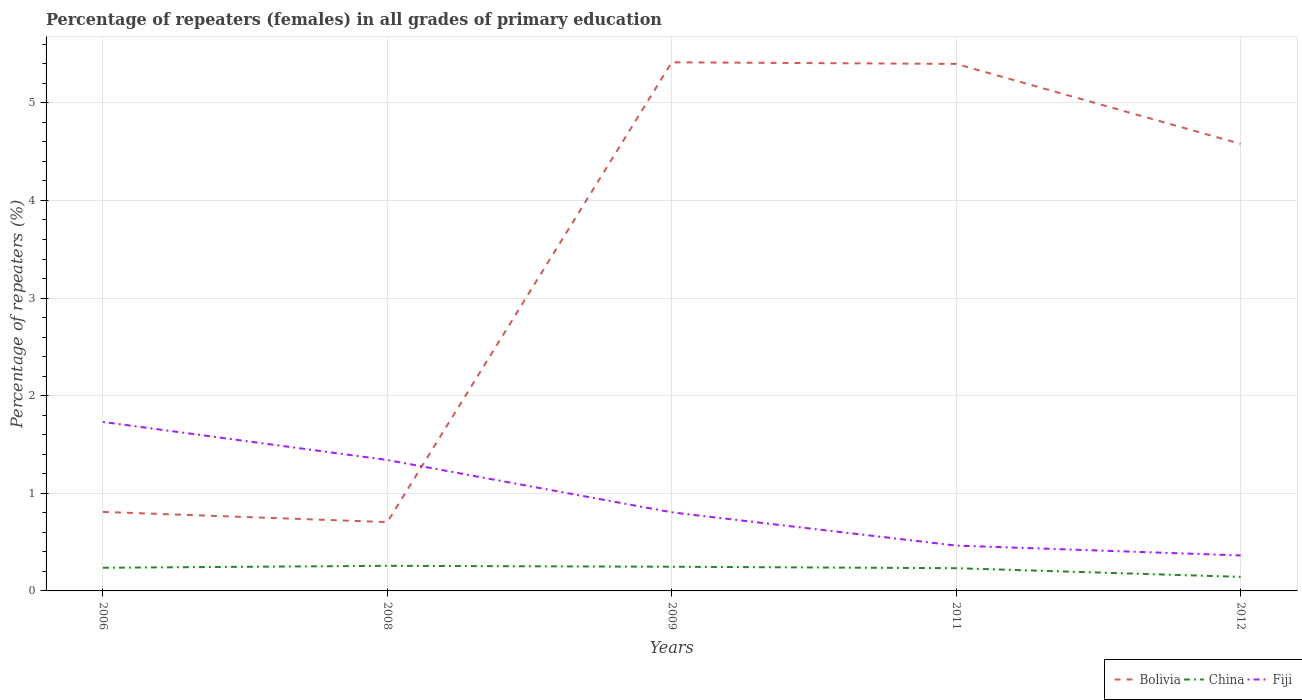Across all years, what is the maximum percentage of repeaters (females) in China?
Your response must be concise. 0.14. In which year was the percentage of repeaters (females) in Bolivia maximum?
Your answer should be very brief. 2008. What is the total percentage of repeaters (females) in Bolivia in the graph?
Offer a terse response. -3.87. What is the difference between the highest and the second highest percentage of repeaters (females) in Fiji?
Offer a terse response. 1.37. What is the difference between the highest and the lowest percentage of repeaters (females) in Bolivia?
Make the answer very short. 3. How many lines are there?
Ensure brevity in your answer.  3. How many years are there in the graph?
Keep it short and to the point. 5. What is the difference between two consecutive major ticks on the Y-axis?
Provide a succinct answer. 1. Are the values on the major ticks of Y-axis written in scientific E-notation?
Offer a very short reply. No. How many legend labels are there?
Your answer should be very brief. 3. What is the title of the graph?
Your answer should be compact. Percentage of repeaters (females) in all grades of primary education. What is the label or title of the X-axis?
Offer a very short reply. Years. What is the label or title of the Y-axis?
Ensure brevity in your answer.  Percentage of repeaters (%). What is the Percentage of repeaters (%) of Bolivia in 2006?
Your response must be concise. 0.81. What is the Percentage of repeaters (%) in China in 2006?
Provide a succinct answer. 0.24. What is the Percentage of repeaters (%) in Fiji in 2006?
Provide a short and direct response. 1.73. What is the Percentage of repeaters (%) in Bolivia in 2008?
Your answer should be very brief. 0.71. What is the Percentage of repeaters (%) in China in 2008?
Provide a succinct answer. 0.26. What is the Percentage of repeaters (%) in Fiji in 2008?
Your answer should be compact. 1.34. What is the Percentage of repeaters (%) of Bolivia in 2009?
Make the answer very short. 5.42. What is the Percentage of repeaters (%) in China in 2009?
Your answer should be very brief. 0.25. What is the Percentage of repeaters (%) of Fiji in 2009?
Provide a succinct answer. 0.8. What is the Percentage of repeaters (%) of Bolivia in 2011?
Keep it short and to the point. 5.4. What is the Percentage of repeaters (%) in China in 2011?
Offer a very short reply. 0.23. What is the Percentage of repeaters (%) in Fiji in 2011?
Your answer should be very brief. 0.46. What is the Percentage of repeaters (%) of Bolivia in 2012?
Keep it short and to the point. 4.58. What is the Percentage of repeaters (%) of China in 2012?
Your response must be concise. 0.14. What is the Percentage of repeaters (%) in Fiji in 2012?
Your response must be concise. 0.36. Across all years, what is the maximum Percentage of repeaters (%) in Bolivia?
Give a very brief answer. 5.42. Across all years, what is the maximum Percentage of repeaters (%) in China?
Provide a short and direct response. 0.26. Across all years, what is the maximum Percentage of repeaters (%) of Fiji?
Provide a succinct answer. 1.73. Across all years, what is the minimum Percentage of repeaters (%) in Bolivia?
Offer a very short reply. 0.71. Across all years, what is the minimum Percentage of repeaters (%) in China?
Provide a succinct answer. 0.14. Across all years, what is the minimum Percentage of repeaters (%) in Fiji?
Your answer should be very brief. 0.36. What is the total Percentage of repeaters (%) of Bolivia in the graph?
Your response must be concise. 16.91. What is the total Percentage of repeaters (%) in China in the graph?
Your answer should be very brief. 1.12. What is the total Percentage of repeaters (%) of Fiji in the graph?
Offer a terse response. 4.71. What is the difference between the Percentage of repeaters (%) of Bolivia in 2006 and that in 2008?
Provide a short and direct response. 0.1. What is the difference between the Percentage of repeaters (%) of China in 2006 and that in 2008?
Your answer should be very brief. -0.02. What is the difference between the Percentage of repeaters (%) in Fiji in 2006 and that in 2008?
Give a very brief answer. 0.39. What is the difference between the Percentage of repeaters (%) in Bolivia in 2006 and that in 2009?
Offer a very short reply. -4.61. What is the difference between the Percentage of repeaters (%) in China in 2006 and that in 2009?
Ensure brevity in your answer.  -0.01. What is the difference between the Percentage of repeaters (%) of Fiji in 2006 and that in 2009?
Make the answer very short. 0.93. What is the difference between the Percentage of repeaters (%) of Bolivia in 2006 and that in 2011?
Provide a short and direct response. -4.59. What is the difference between the Percentage of repeaters (%) of China in 2006 and that in 2011?
Your answer should be compact. 0. What is the difference between the Percentage of repeaters (%) of Fiji in 2006 and that in 2011?
Your answer should be very brief. 1.27. What is the difference between the Percentage of repeaters (%) of Bolivia in 2006 and that in 2012?
Offer a very short reply. -3.77. What is the difference between the Percentage of repeaters (%) of China in 2006 and that in 2012?
Provide a short and direct response. 0.09. What is the difference between the Percentage of repeaters (%) of Fiji in 2006 and that in 2012?
Give a very brief answer. 1.37. What is the difference between the Percentage of repeaters (%) of Bolivia in 2008 and that in 2009?
Provide a succinct answer. -4.71. What is the difference between the Percentage of repeaters (%) of China in 2008 and that in 2009?
Make the answer very short. 0.01. What is the difference between the Percentage of repeaters (%) of Fiji in 2008 and that in 2009?
Make the answer very short. 0.54. What is the difference between the Percentage of repeaters (%) of Bolivia in 2008 and that in 2011?
Your answer should be very brief. -4.69. What is the difference between the Percentage of repeaters (%) of China in 2008 and that in 2011?
Offer a very short reply. 0.02. What is the difference between the Percentage of repeaters (%) in Fiji in 2008 and that in 2011?
Give a very brief answer. 0.88. What is the difference between the Percentage of repeaters (%) in Bolivia in 2008 and that in 2012?
Your answer should be very brief. -3.87. What is the difference between the Percentage of repeaters (%) of China in 2008 and that in 2012?
Ensure brevity in your answer.  0.11. What is the difference between the Percentage of repeaters (%) of Fiji in 2008 and that in 2012?
Provide a short and direct response. 0.98. What is the difference between the Percentage of repeaters (%) of Bolivia in 2009 and that in 2011?
Keep it short and to the point. 0.02. What is the difference between the Percentage of repeaters (%) of China in 2009 and that in 2011?
Make the answer very short. 0.01. What is the difference between the Percentage of repeaters (%) in Fiji in 2009 and that in 2011?
Offer a terse response. 0.34. What is the difference between the Percentage of repeaters (%) of Bolivia in 2009 and that in 2012?
Your answer should be compact. 0.84. What is the difference between the Percentage of repeaters (%) in China in 2009 and that in 2012?
Offer a very short reply. 0.1. What is the difference between the Percentage of repeaters (%) in Fiji in 2009 and that in 2012?
Give a very brief answer. 0.44. What is the difference between the Percentage of repeaters (%) in Bolivia in 2011 and that in 2012?
Provide a succinct answer. 0.82. What is the difference between the Percentage of repeaters (%) in China in 2011 and that in 2012?
Offer a terse response. 0.09. What is the difference between the Percentage of repeaters (%) in Fiji in 2011 and that in 2012?
Offer a terse response. 0.1. What is the difference between the Percentage of repeaters (%) in Bolivia in 2006 and the Percentage of repeaters (%) in China in 2008?
Your answer should be very brief. 0.55. What is the difference between the Percentage of repeaters (%) of Bolivia in 2006 and the Percentage of repeaters (%) of Fiji in 2008?
Offer a terse response. -0.53. What is the difference between the Percentage of repeaters (%) of China in 2006 and the Percentage of repeaters (%) of Fiji in 2008?
Keep it short and to the point. -1.1. What is the difference between the Percentage of repeaters (%) in Bolivia in 2006 and the Percentage of repeaters (%) in China in 2009?
Offer a terse response. 0.56. What is the difference between the Percentage of repeaters (%) of Bolivia in 2006 and the Percentage of repeaters (%) of Fiji in 2009?
Your response must be concise. 0. What is the difference between the Percentage of repeaters (%) of China in 2006 and the Percentage of repeaters (%) of Fiji in 2009?
Give a very brief answer. -0.57. What is the difference between the Percentage of repeaters (%) in Bolivia in 2006 and the Percentage of repeaters (%) in China in 2011?
Ensure brevity in your answer.  0.58. What is the difference between the Percentage of repeaters (%) in Bolivia in 2006 and the Percentage of repeaters (%) in Fiji in 2011?
Keep it short and to the point. 0.34. What is the difference between the Percentage of repeaters (%) of China in 2006 and the Percentage of repeaters (%) of Fiji in 2011?
Provide a short and direct response. -0.23. What is the difference between the Percentage of repeaters (%) of Bolivia in 2006 and the Percentage of repeaters (%) of China in 2012?
Give a very brief answer. 0.67. What is the difference between the Percentage of repeaters (%) in Bolivia in 2006 and the Percentage of repeaters (%) in Fiji in 2012?
Your answer should be very brief. 0.45. What is the difference between the Percentage of repeaters (%) in China in 2006 and the Percentage of repeaters (%) in Fiji in 2012?
Keep it short and to the point. -0.13. What is the difference between the Percentage of repeaters (%) in Bolivia in 2008 and the Percentage of repeaters (%) in China in 2009?
Make the answer very short. 0.46. What is the difference between the Percentage of repeaters (%) of Bolivia in 2008 and the Percentage of repeaters (%) of Fiji in 2009?
Offer a terse response. -0.1. What is the difference between the Percentage of repeaters (%) in China in 2008 and the Percentage of repeaters (%) in Fiji in 2009?
Your answer should be very brief. -0.55. What is the difference between the Percentage of repeaters (%) in Bolivia in 2008 and the Percentage of repeaters (%) in China in 2011?
Ensure brevity in your answer.  0.47. What is the difference between the Percentage of repeaters (%) in Bolivia in 2008 and the Percentage of repeaters (%) in Fiji in 2011?
Your answer should be very brief. 0.24. What is the difference between the Percentage of repeaters (%) in China in 2008 and the Percentage of repeaters (%) in Fiji in 2011?
Offer a very short reply. -0.21. What is the difference between the Percentage of repeaters (%) in Bolivia in 2008 and the Percentage of repeaters (%) in China in 2012?
Your answer should be compact. 0.56. What is the difference between the Percentage of repeaters (%) in Bolivia in 2008 and the Percentage of repeaters (%) in Fiji in 2012?
Offer a very short reply. 0.34. What is the difference between the Percentage of repeaters (%) of China in 2008 and the Percentage of repeaters (%) of Fiji in 2012?
Your answer should be very brief. -0.11. What is the difference between the Percentage of repeaters (%) of Bolivia in 2009 and the Percentage of repeaters (%) of China in 2011?
Offer a terse response. 5.18. What is the difference between the Percentage of repeaters (%) in Bolivia in 2009 and the Percentage of repeaters (%) in Fiji in 2011?
Keep it short and to the point. 4.95. What is the difference between the Percentage of repeaters (%) in China in 2009 and the Percentage of repeaters (%) in Fiji in 2011?
Offer a very short reply. -0.22. What is the difference between the Percentage of repeaters (%) in Bolivia in 2009 and the Percentage of repeaters (%) in China in 2012?
Offer a terse response. 5.27. What is the difference between the Percentage of repeaters (%) of Bolivia in 2009 and the Percentage of repeaters (%) of Fiji in 2012?
Your response must be concise. 5.05. What is the difference between the Percentage of repeaters (%) in China in 2009 and the Percentage of repeaters (%) in Fiji in 2012?
Keep it short and to the point. -0.12. What is the difference between the Percentage of repeaters (%) of Bolivia in 2011 and the Percentage of repeaters (%) of China in 2012?
Offer a very short reply. 5.25. What is the difference between the Percentage of repeaters (%) in Bolivia in 2011 and the Percentage of repeaters (%) in Fiji in 2012?
Your answer should be compact. 5.04. What is the difference between the Percentage of repeaters (%) in China in 2011 and the Percentage of repeaters (%) in Fiji in 2012?
Ensure brevity in your answer.  -0.13. What is the average Percentage of repeaters (%) in Bolivia per year?
Your response must be concise. 3.38. What is the average Percentage of repeaters (%) of China per year?
Provide a succinct answer. 0.22. What is the average Percentage of repeaters (%) in Fiji per year?
Provide a succinct answer. 0.94. In the year 2006, what is the difference between the Percentage of repeaters (%) in Bolivia and Percentage of repeaters (%) in China?
Provide a succinct answer. 0.57. In the year 2006, what is the difference between the Percentage of repeaters (%) in Bolivia and Percentage of repeaters (%) in Fiji?
Your response must be concise. -0.92. In the year 2006, what is the difference between the Percentage of repeaters (%) of China and Percentage of repeaters (%) of Fiji?
Keep it short and to the point. -1.49. In the year 2008, what is the difference between the Percentage of repeaters (%) in Bolivia and Percentage of repeaters (%) in China?
Provide a succinct answer. 0.45. In the year 2008, what is the difference between the Percentage of repeaters (%) of Bolivia and Percentage of repeaters (%) of Fiji?
Give a very brief answer. -0.64. In the year 2008, what is the difference between the Percentage of repeaters (%) of China and Percentage of repeaters (%) of Fiji?
Your answer should be very brief. -1.08. In the year 2009, what is the difference between the Percentage of repeaters (%) in Bolivia and Percentage of repeaters (%) in China?
Make the answer very short. 5.17. In the year 2009, what is the difference between the Percentage of repeaters (%) of Bolivia and Percentage of repeaters (%) of Fiji?
Your response must be concise. 4.61. In the year 2009, what is the difference between the Percentage of repeaters (%) in China and Percentage of repeaters (%) in Fiji?
Your answer should be very brief. -0.56. In the year 2011, what is the difference between the Percentage of repeaters (%) in Bolivia and Percentage of repeaters (%) in China?
Your answer should be very brief. 5.17. In the year 2011, what is the difference between the Percentage of repeaters (%) in Bolivia and Percentage of repeaters (%) in Fiji?
Make the answer very short. 4.93. In the year 2011, what is the difference between the Percentage of repeaters (%) in China and Percentage of repeaters (%) in Fiji?
Offer a terse response. -0.23. In the year 2012, what is the difference between the Percentage of repeaters (%) of Bolivia and Percentage of repeaters (%) of China?
Ensure brevity in your answer.  4.44. In the year 2012, what is the difference between the Percentage of repeaters (%) of Bolivia and Percentage of repeaters (%) of Fiji?
Your answer should be very brief. 4.22. In the year 2012, what is the difference between the Percentage of repeaters (%) of China and Percentage of repeaters (%) of Fiji?
Your response must be concise. -0.22. What is the ratio of the Percentage of repeaters (%) of Bolivia in 2006 to that in 2008?
Your response must be concise. 1.15. What is the ratio of the Percentage of repeaters (%) of China in 2006 to that in 2008?
Keep it short and to the point. 0.92. What is the ratio of the Percentage of repeaters (%) in Fiji in 2006 to that in 2008?
Offer a very short reply. 1.29. What is the ratio of the Percentage of repeaters (%) of Bolivia in 2006 to that in 2009?
Give a very brief answer. 0.15. What is the ratio of the Percentage of repeaters (%) in China in 2006 to that in 2009?
Your answer should be compact. 0.96. What is the ratio of the Percentage of repeaters (%) in Fiji in 2006 to that in 2009?
Your answer should be compact. 2.15. What is the ratio of the Percentage of repeaters (%) of Bolivia in 2006 to that in 2011?
Offer a terse response. 0.15. What is the ratio of the Percentage of repeaters (%) in China in 2006 to that in 2011?
Give a very brief answer. 1.02. What is the ratio of the Percentage of repeaters (%) in Fiji in 2006 to that in 2011?
Make the answer very short. 3.73. What is the ratio of the Percentage of repeaters (%) in Bolivia in 2006 to that in 2012?
Your answer should be compact. 0.18. What is the ratio of the Percentage of repeaters (%) in China in 2006 to that in 2012?
Your response must be concise. 1.65. What is the ratio of the Percentage of repeaters (%) in Fiji in 2006 to that in 2012?
Provide a succinct answer. 4.76. What is the ratio of the Percentage of repeaters (%) in Bolivia in 2008 to that in 2009?
Make the answer very short. 0.13. What is the ratio of the Percentage of repeaters (%) in China in 2008 to that in 2009?
Make the answer very short. 1.04. What is the ratio of the Percentage of repeaters (%) in Fiji in 2008 to that in 2009?
Your response must be concise. 1.67. What is the ratio of the Percentage of repeaters (%) of Bolivia in 2008 to that in 2011?
Ensure brevity in your answer.  0.13. What is the ratio of the Percentage of repeaters (%) of China in 2008 to that in 2011?
Give a very brief answer. 1.1. What is the ratio of the Percentage of repeaters (%) of Fiji in 2008 to that in 2011?
Offer a terse response. 2.89. What is the ratio of the Percentage of repeaters (%) of Bolivia in 2008 to that in 2012?
Your response must be concise. 0.15. What is the ratio of the Percentage of repeaters (%) in China in 2008 to that in 2012?
Ensure brevity in your answer.  1.79. What is the ratio of the Percentage of repeaters (%) in Fiji in 2008 to that in 2012?
Your response must be concise. 3.69. What is the ratio of the Percentage of repeaters (%) of China in 2009 to that in 2011?
Give a very brief answer. 1.06. What is the ratio of the Percentage of repeaters (%) in Fiji in 2009 to that in 2011?
Your response must be concise. 1.73. What is the ratio of the Percentage of repeaters (%) in Bolivia in 2009 to that in 2012?
Your response must be concise. 1.18. What is the ratio of the Percentage of repeaters (%) in China in 2009 to that in 2012?
Keep it short and to the point. 1.72. What is the ratio of the Percentage of repeaters (%) in Fiji in 2009 to that in 2012?
Make the answer very short. 2.21. What is the ratio of the Percentage of repeaters (%) of Bolivia in 2011 to that in 2012?
Keep it short and to the point. 1.18. What is the ratio of the Percentage of repeaters (%) of China in 2011 to that in 2012?
Make the answer very short. 1.62. What is the ratio of the Percentage of repeaters (%) of Fiji in 2011 to that in 2012?
Offer a very short reply. 1.28. What is the difference between the highest and the second highest Percentage of repeaters (%) of Bolivia?
Ensure brevity in your answer.  0.02. What is the difference between the highest and the second highest Percentage of repeaters (%) in China?
Provide a short and direct response. 0.01. What is the difference between the highest and the second highest Percentage of repeaters (%) in Fiji?
Your answer should be very brief. 0.39. What is the difference between the highest and the lowest Percentage of repeaters (%) in Bolivia?
Make the answer very short. 4.71. What is the difference between the highest and the lowest Percentage of repeaters (%) in China?
Your response must be concise. 0.11. What is the difference between the highest and the lowest Percentage of repeaters (%) of Fiji?
Make the answer very short. 1.37. 